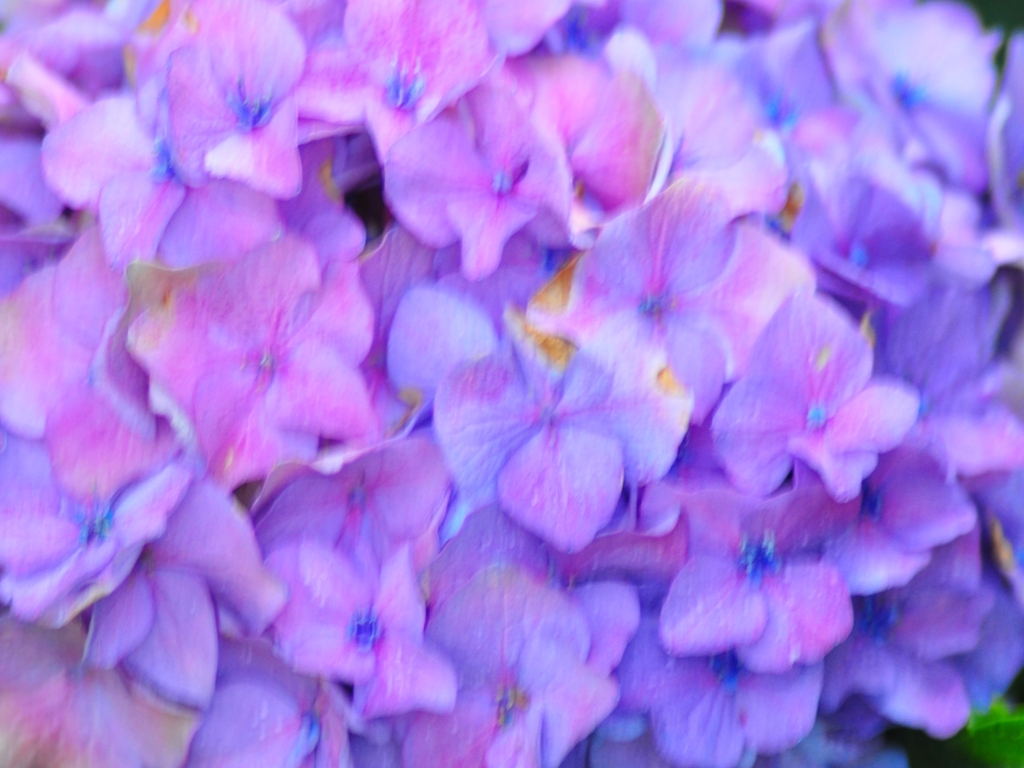Does the picture have vibrant color contrast? Indeed, the image displays a captivating array of vibrant colors with a stunning contrast between the shades of purple, blue, and subtle hints of pink found in the petals, as well as the deeper green tones in the background, giving the composition a lively and dynamic feel. 